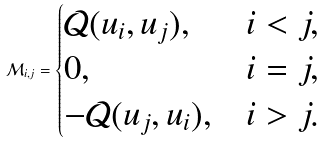<formula> <loc_0><loc_0><loc_500><loc_500>\mathcal { M } _ { i , j } = \begin{cases} \mathcal { Q } ( u _ { i } , u _ { j } ) , & i < j , \\ 0 , & i = j , \\ - \mathcal { Q } ( u _ { j } , u _ { i } ) , & i > j . \end{cases}</formula> 